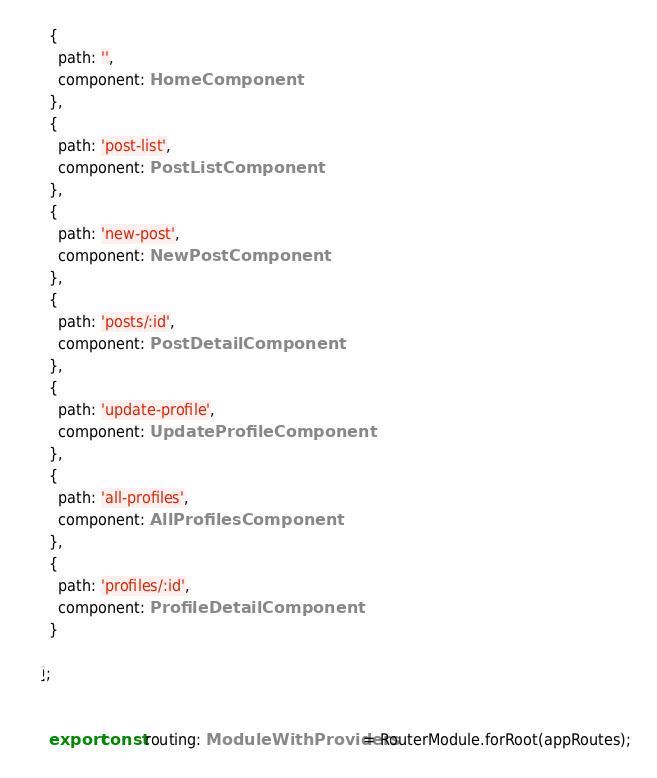Convert code to text. <code><loc_0><loc_0><loc_500><loc_500><_TypeScript_>  {
    path: '',
    component: HomeComponent
  },
  {
    path: 'post-list',
    component: PostListComponent
  },
  {
    path: 'new-post',
    component: NewPostComponent
  },
  {
    path: 'posts/:id',
    component: PostDetailComponent
  },
  {
    path: 'update-profile',
    component: UpdateProfileComponent
  },
  {
    path: 'all-profiles',
    component: AllProfilesComponent
  },
  {
    path: 'profiles/:id',
    component: ProfileDetailComponent
  }

];


  export const routing: ModuleWithProviders = RouterModule.forRoot(appRoutes);
</code> 